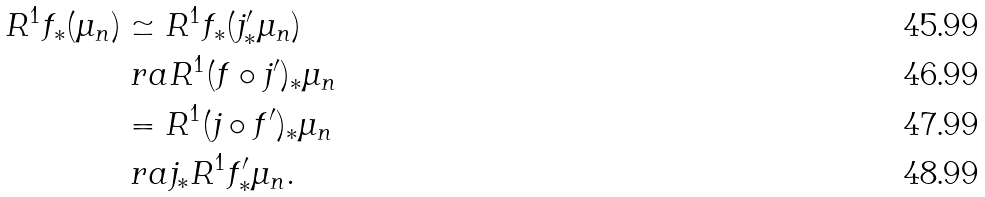Convert formula to latex. <formula><loc_0><loc_0><loc_500><loc_500>R ^ { 1 } f _ { * } ( \mu _ { n } ) & \simeq R ^ { 1 } f _ { * } ( j ^ { \prime } _ { * } \mu _ { n } ) \\ & \ r a R ^ { 1 } ( f \circ j ^ { \prime } ) _ { * } \mu _ { n } \\ & = R ^ { 1 } ( j \circ f ^ { \prime } ) _ { * } \mu _ { n } \\ & \ r a j _ { * } R ^ { 1 } f ^ { \prime } _ { * } \mu _ { n } .</formula> 